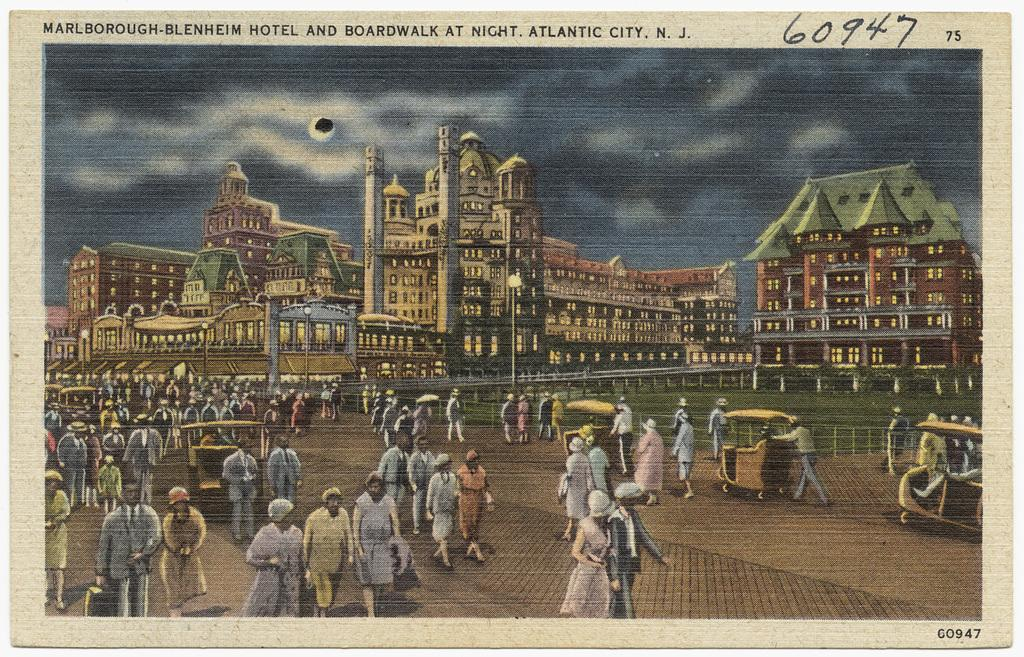What is the main subject of the image? The image contains a picture. What can be seen in the sky of the picture? The sky with clouds is visible in the picture. What type of structures are present in the picture? There are buildings in the picture. What are some other objects visible in the picture? Street poles, street lights, and carts are present in the picture. What is happening with the people in the picture? Persons walking on the road are depicted in the picture. Can you see a baby wearing a coat in the fog in the image? There is no baby, coat, or fog present in the image. 